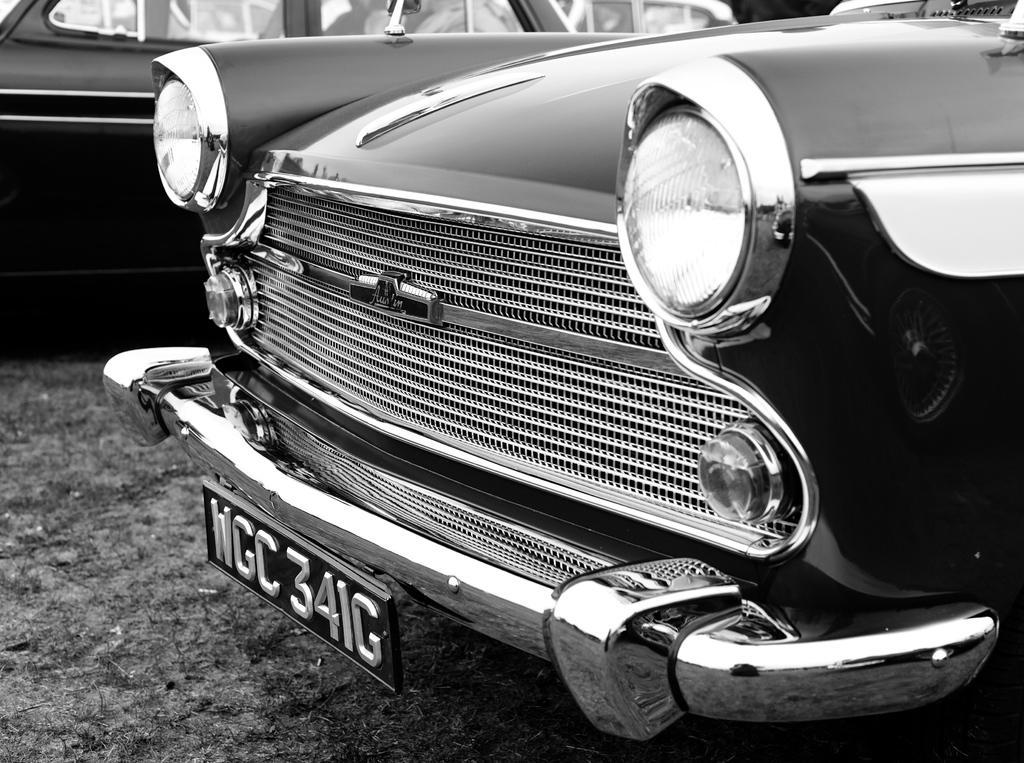Describe this image in one or two sentences. This is a black and white image. There is a car which has a registration plate. There is another car at the back. 